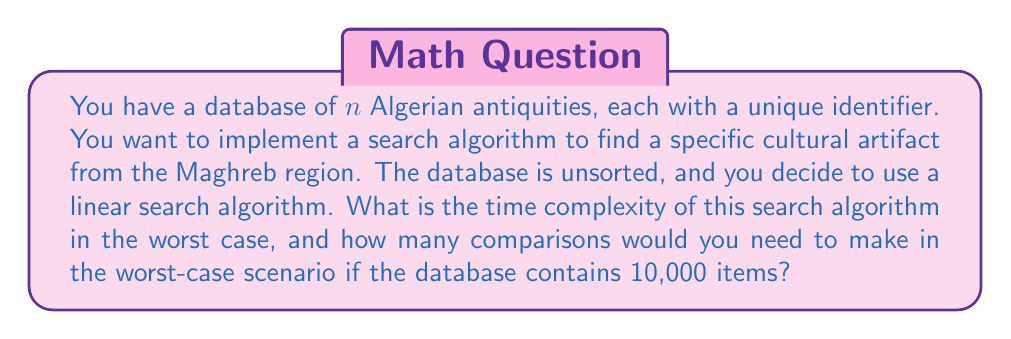Solve this math problem. To solve this problem, let's break it down step by step:

1. Understanding the algorithm:
   Linear search involves checking each item in the database sequentially until the desired artifact is found or the end of the database is reached.

2. Time complexity analysis:
   - In the worst case, the artifact we're looking for is the last item in the database or not present at all.
   - This means we would need to check every single item in the database.
   - The number of comparisons is directly proportional to the number of items, $n$.
   - Therefore, the time complexity in the worst case is $O(n)$.

3. Worst-case scenario for 10,000 items:
   - With 10,000 items in the database, in the worst case, we would need to check all 10,000 items.
   - This means we would perform 10,000 comparisons.

4. Mathematical representation:
   Let $T(n)$ be the number of comparisons in the worst case for $n$ items.
   $$T(n) = n$$

   For $n = 10,000$:
   $$T(10,000) = 10,000$$

Thus, the time complexity is $O(n)$, and for a database of 10,000 Algerian antiquities, we would need to make 10,000 comparisons in the worst case.
Answer: Time complexity: $O(n)$
Number of comparisons for 10,000 items: 10,000 